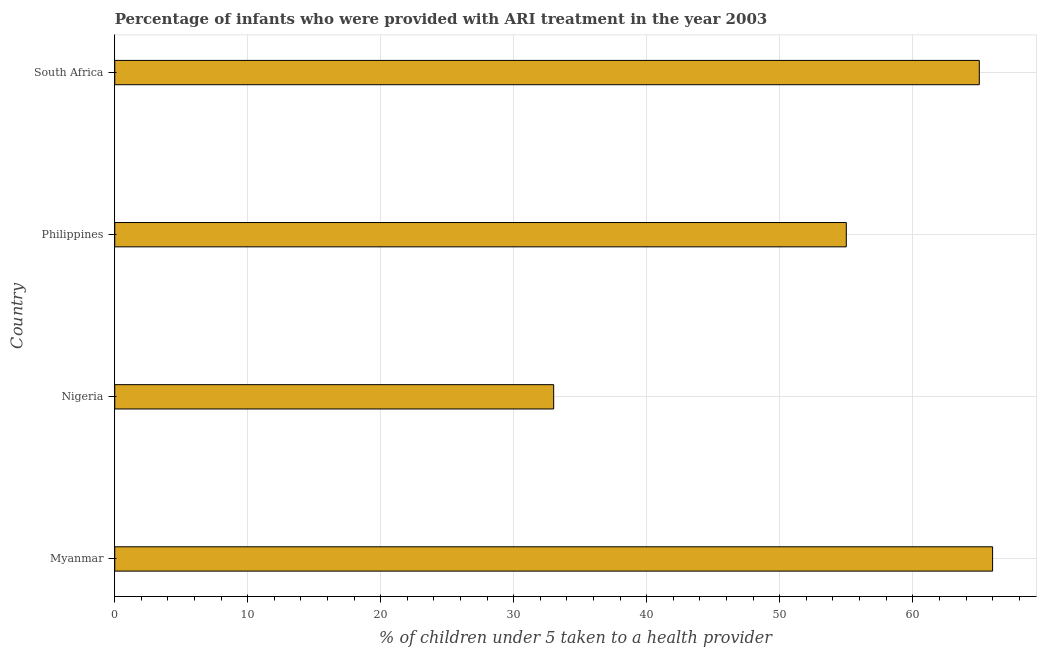Does the graph contain grids?
Your response must be concise. Yes. What is the title of the graph?
Provide a succinct answer. Percentage of infants who were provided with ARI treatment in the year 2003. What is the label or title of the X-axis?
Offer a terse response. % of children under 5 taken to a health provider. Across all countries, what is the maximum percentage of children who were provided with ari treatment?
Provide a succinct answer. 66. Across all countries, what is the minimum percentage of children who were provided with ari treatment?
Give a very brief answer. 33. In which country was the percentage of children who were provided with ari treatment maximum?
Make the answer very short. Myanmar. In which country was the percentage of children who were provided with ari treatment minimum?
Your response must be concise. Nigeria. What is the sum of the percentage of children who were provided with ari treatment?
Provide a succinct answer. 219. What is the difference between the percentage of children who were provided with ari treatment in Nigeria and Philippines?
Provide a short and direct response. -22. What is the average percentage of children who were provided with ari treatment per country?
Ensure brevity in your answer.  54.75. What is the median percentage of children who were provided with ari treatment?
Give a very brief answer. 60. What is the ratio of the percentage of children who were provided with ari treatment in Nigeria to that in South Africa?
Provide a short and direct response. 0.51. Is the difference between the percentage of children who were provided with ari treatment in Philippines and South Africa greater than the difference between any two countries?
Ensure brevity in your answer.  No. What is the difference between the highest and the second highest percentage of children who were provided with ari treatment?
Your answer should be compact. 1. Is the sum of the percentage of children who were provided with ari treatment in Nigeria and South Africa greater than the maximum percentage of children who were provided with ari treatment across all countries?
Give a very brief answer. Yes. Are the values on the major ticks of X-axis written in scientific E-notation?
Offer a very short reply. No. What is the % of children under 5 taken to a health provider of Nigeria?
Make the answer very short. 33. What is the % of children under 5 taken to a health provider in South Africa?
Your answer should be compact. 65. What is the difference between the % of children under 5 taken to a health provider in Nigeria and Philippines?
Your answer should be very brief. -22. What is the difference between the % of children under 5 taken to a health provider in Nigeria and South Africa?
Your response must be concise. -32. What is the ratio of the % of children under 5 taken to a health provider in Myanmar to that in Nigeria?
Provide a short and direct response. 2. What is the ratio of the % of children under 5 taken to a health provider in Myanmar to that in South Africa?
Your answer should be very brief. 1.01. What is the ratio of the % of children under 5 taken to a health provider in Nigeria to that in South Africa?
Offer a very short reply. 0.51. What is the ratio of the % of children under 5 taken to a health provider in Philippines to that in South Africa?
Provide a succinct answer. 0.85. 